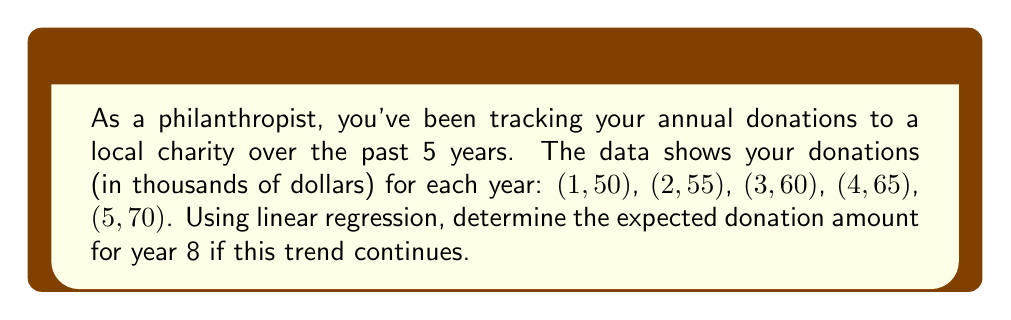Can you solve this math problem? To solve this problem using linear regression, we'll follow these steps:

1. Calculate the means of x (years) and y (donations):
   $\bar{x} = \frac{1 + 2 + 3 + 4 + 5}{5} = 3$
   $\bar{y} = \frac{50 + 55 + 60 + 65 + 70}{5} = 60$

2. Calculate the slope (m) using the formula:
   $m = \frac{\sum(x_i - \bar{x})(y_i - \bar{y})}{\sum(x_i - \bar{x})^2}$

   $\sum(x_i - \bar{x})(y_i - \bar{y}) = (-2)(-10) + (-1)(-5) + (0)(0) + (1)(5) + (2)(10) = 50$
   $\sum(x_i - \bar{x})^2 = (-2)^2 + (-1)^2 + (0)^2 + (1)^2 + (2)^2 = 10$

   $m = \frac{50}{10} = 5$

3. Calculate the y-intercept (b) using the formula:
   $b = \bar{y} - m\bar{x} = 60 - 5(3) = 45$

4. The linear regression equation is:
   $y = mx + b = 5x + 45$

5. To find the expected donation for year 8, substitute x = 8:
   $y = 5(8) + 45 = 85$

Therefore, the expected donation amount for year 8 is $85,000.
Answer: $85,000 